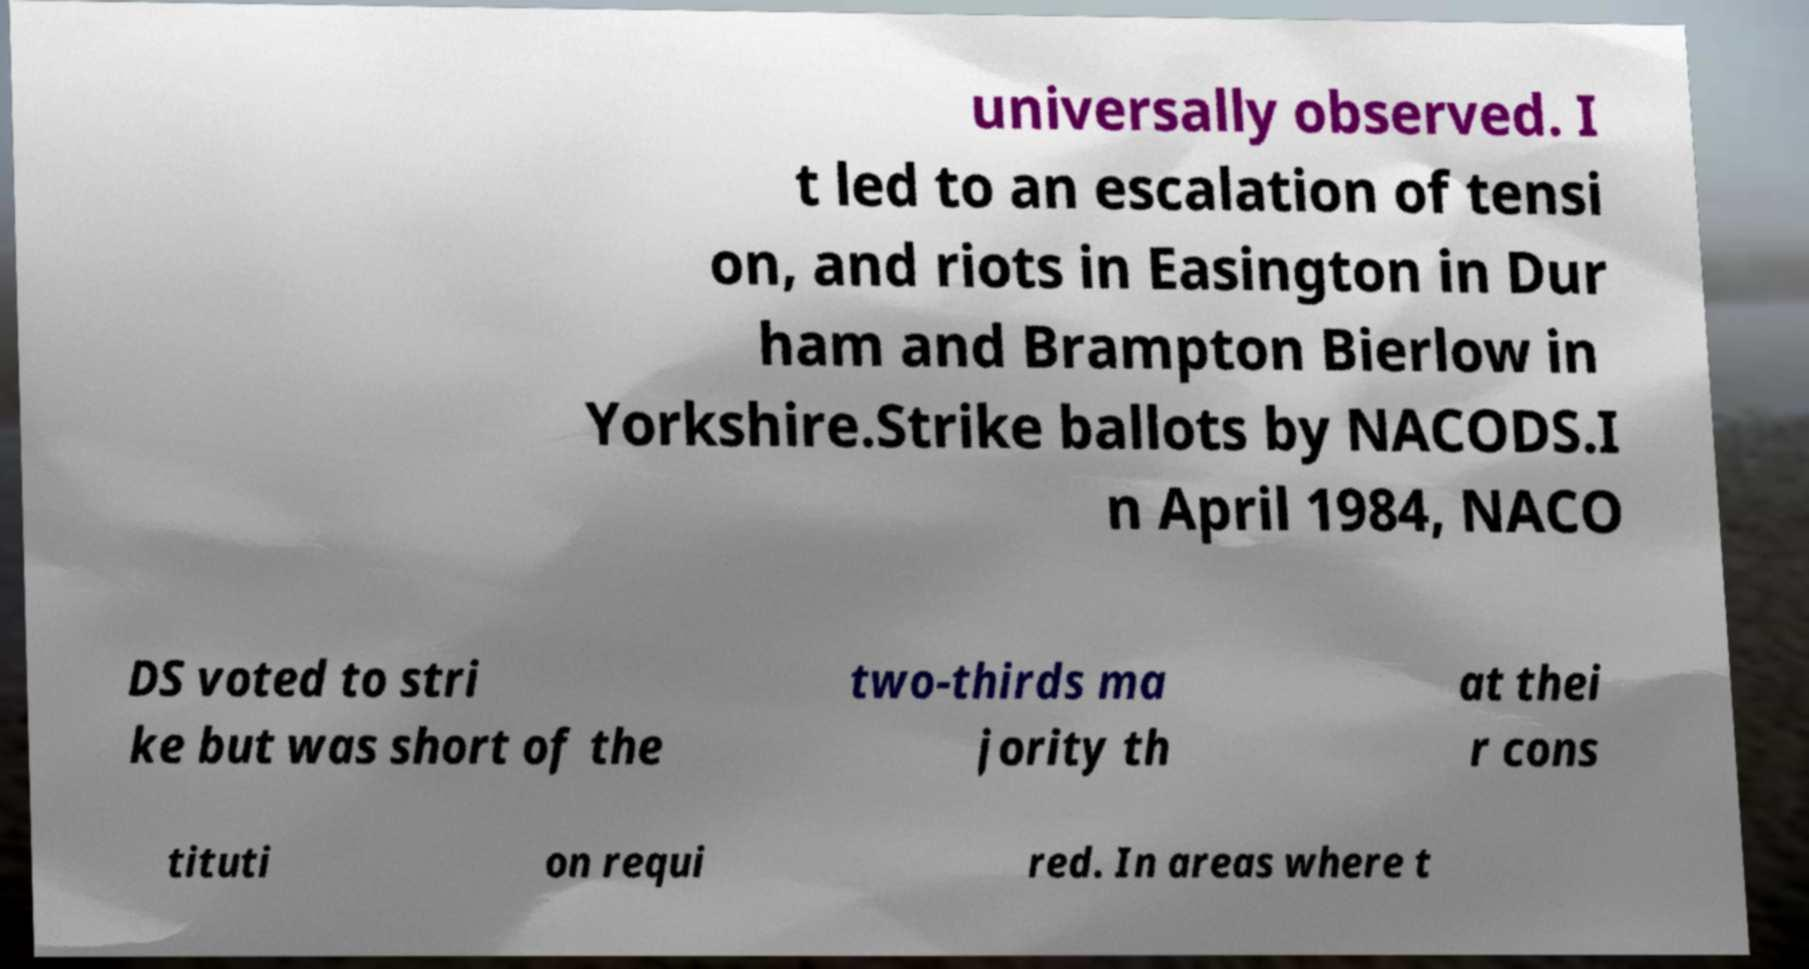Could you extract and type out the text from this image? universally observed. I t led to an escalation of tensi on, and riots in Easington in Dur ham and Brampton Bierlow in Yorkshire.Strike ballots by NACODS.I n April 1984, NACO DS voted to stri ke but was short of the two-thirds ma jority th at thei r cons tituti on requi red. In areas where t 